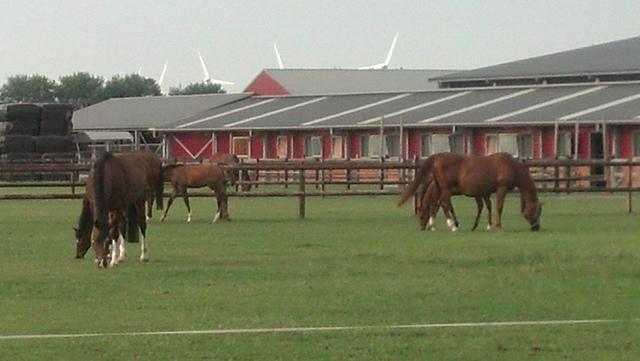How many horses are in the photo?
Give a very brief answer. 3. 